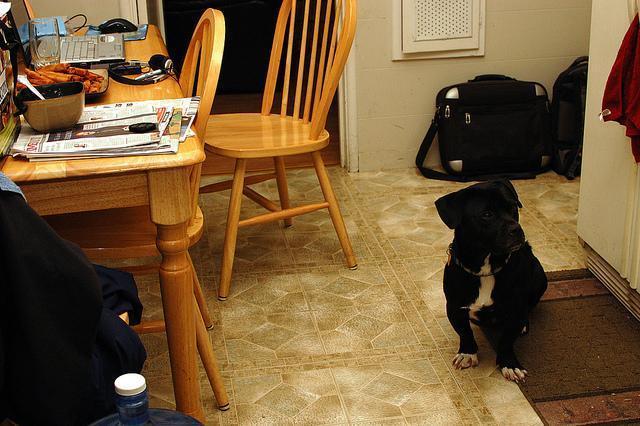How many chairs are there?
Give a very brief answer. 2. How many backpacks can be seen?
Give a very brief answer. 2. 